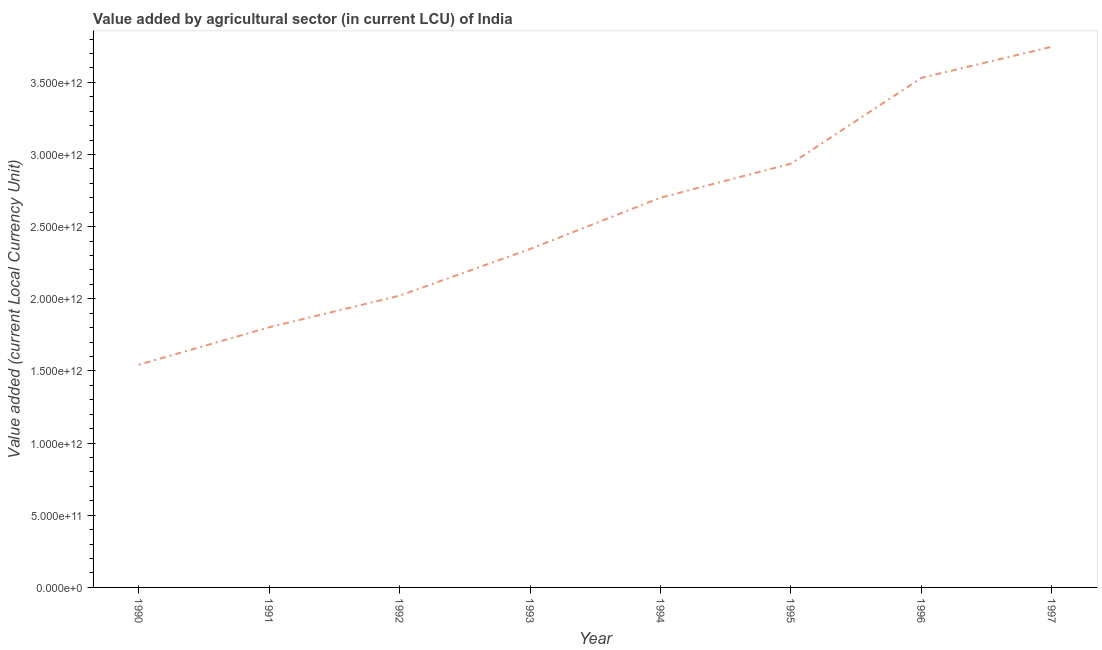What is the value added by agriculture sector in 1992?
Keep it short and to the point. 2.02e+12. Across all years, what is the maximum value added by agriculture sector?
Keep it short and to the point. 3.75e+12. Across all years, what is the minimum value added by agriculture sector?
Your answer should be very brief. 1.54e+12. In which year was the value added by agriculture sector maximum?
Provide a succinct answer. 1997. What is the sum of the value added by agriculture sector?
Offer a terse response. 2.06e+13. What is the difference between the value added by agriculture sector in 1990 and 1997?
Your answer should be very brief. -2.20e+12. What is the average value added by agriculture sector per year?
Provide a succinct answer. 2.58e+12. What is the median value added by agriculture sector?
Provide a succinct answer. 2.52e+12. What is the ratio of the value added by agriculture sector in 1991 to that in 1992?
Offer a terse response. 0.89. Is the value added by agriculture sector in 1993 less than that in 1994?
Keep it short and to the point. Yes. Is the difference between the value added by agriculture sector in 1991 and 1994 greater than the difference between any two years?
Keep it short and to the point. No. What is the difference between the highest and the second highest value added by agriculture sector?
Ensure brevity in your answer.  2.16e+11. What is the difference between the highest and the lowest value added by agriculture sector?
Your response must be concise. 2.20e+12. In how many years, is the value added by agriculture sector greater than the average value added by agriculture sector taken over all years?
Give a very brief answer. 4. Does the value added by agriculture sector monotonically increase over the years?
Your answer should be very brief. Yes. How many lines are there?
Offer a terse response. 1. What is the difference between two consecutive major ticks on the Y-axis?
Keep it short and to the point. 5.00e+11. Are the values on the major ticks of Y-axis written in scientific E-notation?
Offer a very short reply. Yes. Does the graph contain any zero values?
Give a very brief answer. No. What is the title of the graph?
Your answer should be very brief. Value added by agricultural sector (in current LCU) of India. What is the label or title of the Y-axis?
Make the answer very short. Value added (current Local Currency Unit). What is the Value added (current Local Currency Unit) in 1990?
Give a very brief answer. 1.54e+12. What is the Value added (current Local Currency Unit) in 1991?
Offer a very short reply. 1.80e+12. What is the Value added (current Local Currency Unit) of 1992?
Offer a terse response. 2.02e+12. What is the Value added (current Local Currency Unit) of 1993?
Ensure brevity in your answer.  2.35e+12. What is the Value added (current Local Currency Unit) in 1994?
Your response must be concise. 2.70e+12. What is the Value added (current Local Currency Unit) of 1995?
Ensure brevity in your answer.  2.94e+12. What is the Value added (current Local Currency Unit) of 1996?
Offer a very short reply. 3.53e+12. What is the Value added (current Local Currency Unit) of 1997?
Your answer should be compact. 3.75e+12. What is the difference between the Value added (current Local Currency Unit) in 1990 and 1991?
Ensure brevity in your answer.  -2.60e+11. What is the difference between the Value added (current Local Currency Unit) in 1990 and 1992?
Your response must be concise. -4.79e+11. What is the difference between the Value added (current Local Currency Unit) in 1990 and 1993?
Offer a very short reply. -8.02e+11. What is the difference between the Value added (current Local Currency Unit) in 1990 and 1994?
Ensure brevity in your answer.  -1.16e+12. What is the difference between the Value added (current Local Currency Unit) in 1990 and 1995?
Your response must be concise. -1.39e+12. What is the difference between the Value added (current Local Currency Unit) in 1990 and 1996?
Offer a terse response. -1.99e+12. What is the difference between the Value added (current Local Currency Unit) in 1990 and 1997?
Ensure brevity in your answer.  -2.20e+12. What is the difference between the Value added (current Local Currency Unit) in 1991 and 1992?
Give a very brief answer. -2.19e+11. What is the difference between the Value added (current Local Currency Unit) in 1991 and 1993?
Your answer should be very brief. -5.43e+11. What is the difference between the Value added (current Local Currency Unit) in 1991 and 1994?
Your response must be concise. -8.98e+11. What is the difference between the Value added (current Local Currency Unit) in 1991 and 1995?
Your answer should be compact. -1.13e+12. What is the difference between the Value added (current Local Currency Unit) in 1991 and 1996?
Offer a terse response. -1.73e+12. What is the difference between the Value added (current Local Currency Unit) in 1991 and 1997?
Offer a terse response. -1.94e+12. What is the difference between the Value added (current Local Currency Unit) in 1992 and 1993?
Give a very brief answer. -3.23e+11. What is the difference between the Value added (current Local Currency Unit) in 1992 and 1994?
Provide a succinct answer. -6.79e+11. What is the difference between the Value added (current Local Currency Unit) in 1992 and 1995?
Make the answer very short. -9.15e+11. What is the difference between the Value added (current Local Currency Unit) in 1992 and 1996?
Offer a terse response. -1.51e+12. What is the difference between the Value added (current Local Currency Unit) in 1992 and 1997?
Provide a succinct answer. -1.73e+12. What is the difference between the Value added (current Local Currency Unit) in 1993 and 1994?
Give a very brief answer. -3.55e+11. What is the difference between the Value added (current Local Currency Unit) in 1993 and 1995?
Provide a short and direct response. -5.91e+11. What is the difference between the Value added (current Local Currency Unit) in 1993 and 1996?
Provide a short and direct response. -1.19e+12. What is the difference between the Value added (current Local Currency Unit) in 1993 and 1997?
Your answer should be very brief. -1.40e+12. What is the difference between the Value added (current Local Currency Unit) in 1994 and 1995?
Your answer should be compact. -2.36e+11. What is the difference between the Value added (current Local Currency Unit) in 1994 and 1996?
Your answer should be very brief. -8.30e+11. What is the difference between the Value added (current Local Currency Unit) in 1994 and 1997?
Offer a very short reply. -1.05e+12. What is the difference between the Value added (current Local Currency Unit) in 1995 and 1996?
Offer a very short reply. -5.94e+11. What is the difference between the Value added (current Local Currency Unit) in 1995 and 1997?
Provide a short and direct response. -8.10e+11. What is the difference between the Value added (current Local Currency Unit) in 1996 and 1997?
Provide a succinct answer. -2.16e+11. What is the ratio of the Value added (current Local Currency Unit) in 1990 to that in 1991?
Provide a short and direct response. 0.86. What is the ratio of the Value added (current Local Currency Unit) in 1990 to that in 1992?
Keep it short and to the point. 0.76. What is the ratio of the Value added (current Local Currency Unit) in 1990 to that in 1993?
Offer a very short reply. 0.66. What is the ratio of the Value added (current Local Currency Unit) in 1990 to that in 1994?
Your answer should be compact. 0.57. What is the ratio of the Value added (current Local Currency Unit) in 1990 to that in 1995?
Provide a short and direct response. 0.53. What is the ratio of the Value added (current Local Currency Unit) in 1990 to that in 1996?
Provide a succinct answer. 0.44. What is the ratio of the Value added (current Local Currency Unit) in 1990 to that in 1997?
Give a very brief answer. 0.41. What is the ratio of the Value added (current Local Currency Unit) in 1991 to that in 1992?
Ensure brevity in your answer.  0.89. What is the ratio of the Value added (current Local Currency Unit) in 1991 to that in 1993?
Ensure brevity in your answer.  0.77. What is the ratio of the Value added (current Local Currency Unit) in 1991 to that in 1994?
Keep it short and to the point. 0.67. What is the ratio of the Value added (current Local Currency Unit) in 1991 to that in 1995?
Your response must be concise. 0.61. What is the ratio of the Value added (current Local Currency Unit) in 1991 to that in 1996?
Provide a short and direct response. 0.51. What is the ratio of the Value added (current Local Currency Unit) in 1991 to that in 1997?
Ensure brevity in your answer.  0.48. What is the ratio of the Value added (current Local Currency Unit) in 1992 to that in 1993?
Give a very brief answer. 0.86. What is the ratio of the Value added (current Local Currency Unit) in 1992 to that in 1994?
Offer a terse response. 0.75. What is the ratio of the Value added (current Local Currency Unit) in 1992 to that in 1995?
Offer a very short reply. 0.69. What is the ratio of the Value added (current Local Currency Unit) in 1992 to that in 1996?
Your response must be concise. 0.57. What is the ratio of the Value added (current Local Currency Unit) in 1992 to that in 1997?
Provide a short and direct response. 0.54. What is the ratio of the Value added (current Local Currency Unit) in 1993 to that in 1994?
Make the answer very short. 0.87. What is the ratio of the Value added (current Local Currency Unit) in 1993 to that in 1995?
Make the answer very short. 0.8. What is the ratio of the Value added (current Local Currency Unit) in 1993 to that in 1996?
Ensure brevity in your answer.  0.66. What is the ratio of the Value added (current Local Currency Unit) in 1993 to that in 1997?
Your answer should be compact. 0.63. What is the ratio of the Value added (current Local Currency Unit) in 1994 to that in 1995?
Offer a terse response. 0.92. What is the ratio of the Value added (current Local Currency Unit) in 1994 to that in 1996?
Keep it short and to the point. 0.77. What is the ratio of the Value added (current Local Currency Unit) in 1994 to that in 1997?
Provide a succinct answer. 0.72. What is the ratio of the Value added (current Local Currency Unit) in 1995 to that in 1996?
Your answer should be very brief. 0.83. What is the ratio of the Value added (current Local Currency Unit) in 1995 to that in 1997?
Give a very brief answer. 0.78. What is the ratio of the Value added (current Local Currency Unit) in 1996 to that in 1997?
Give a very brief answer. 0.94. 